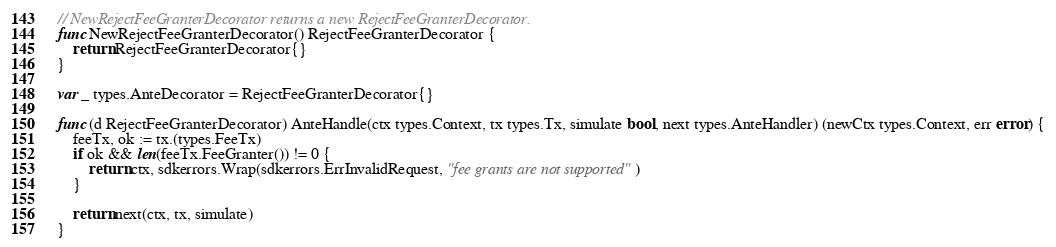Convert code to text. <code><loc_0><loc_0><loc_500><loc_500><_Go_>// NewRejectFeeGranterDecorator returns a new RejectFeeGranterDecorator.
func NewRejectFeeGranterDecorator() RejectFeeGranterDecorator {
	return RejectFeeGranterDecorator{}
}

var _ types.AnteDecorator = RejectFeeGranterDecorator{}

func (d RejectFeeGranterDecorator) AnteHandle(ctx types.Context, tx types.Tx, simulate bool, next types.AnteHandler) (newCtx types.Context, err error) {
	feeTx, ok := tx.(types.FeeTx)
	if ok && len(feeTx.FeeGranter()) != 0 {
		return ctx, sdkerrors.Wrap(sdkerrors.ErrInvalidRequest, "fee grants are not supported")
	}

	return next(ctx, tx, simulate)
}
</code> 